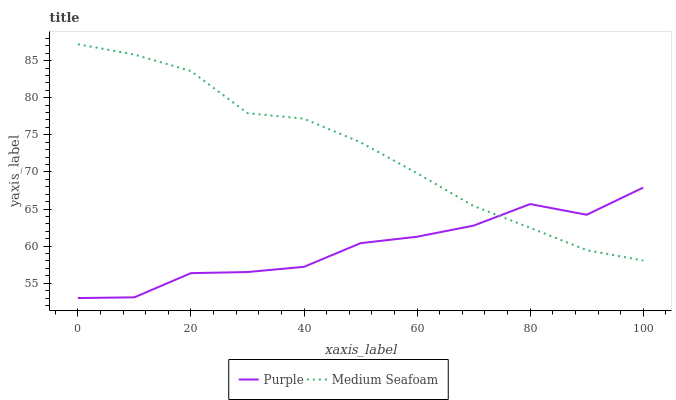Does Purple have the minimum area under the curve?
Answer yes or no. Yes. Does Medium Seafoam have the maximum area under the curve?
Answer yes or no. Yes. Does Medium Seafoam have the minimum area under the curve?
Answer yes or no. No. Is Medium Seafoam the smoothest?
Answer yes or no. Yes. Is Purple the roughest?
Answer yes or no. Yes. Is Medium Seafoam the roughest?
Answer yes or no. No. Does Purple have the lowest value?
Answer yes or no. Yes. Does Medium Seafoam have the lowest value?
Answer yes or no. No. Does Medium Seafoam have the highest value?
Answer yes or no. Yes. Does Medium Seafoam intersect Purple?
Answer yes or no. Yes. Is Medium Seafoam less than Purple?
Answer yes or no. No. Is Medium Seafoam greater than Purple?
Answer yes or no. No. 